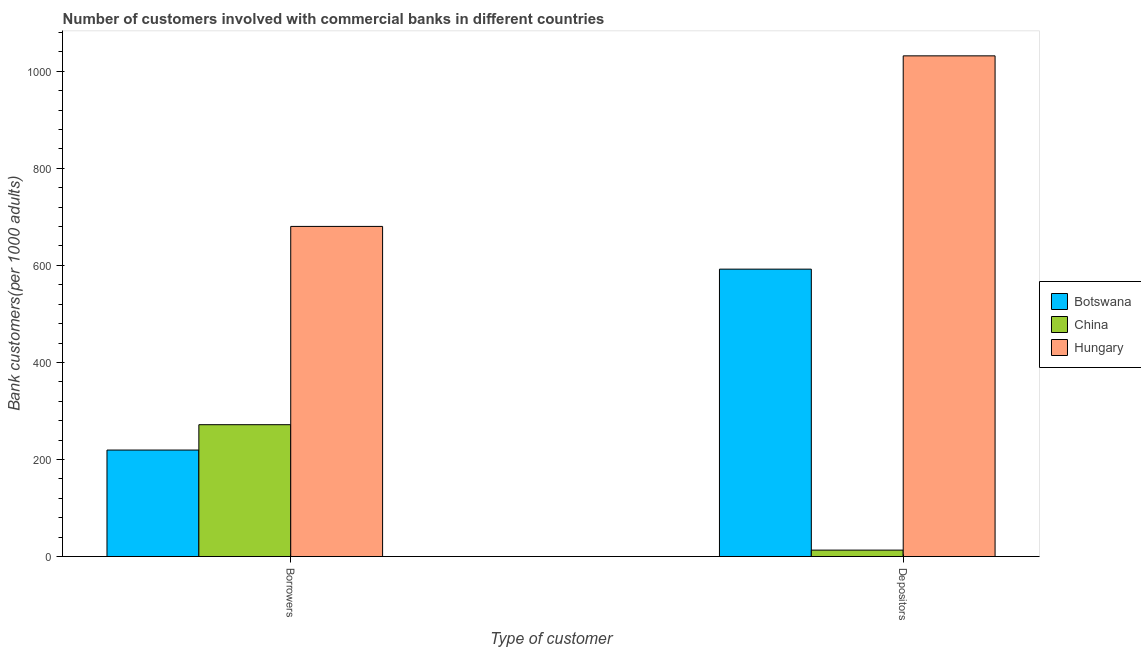How many different coloured bars are there?
Provide a succinct answer. 3. What is the label of the 1st group of bars from the left?
Offer a very short reply. Borrowers. What is the number of borrowers in Botswana?
Ensure brevity in your answer.  219.44. Across all countries, what is the maximum number of borrowers?
Give a very brief answer. 680.32. Across all countries, what is the minimum number of borrowers?
Your answer should be compact. 219.44. In which country was the number of depositors maximum?
Keep it short and to the point. Hungary. In which country was the number of borrowers minimum?
Provide a short and direct response. Botswana. What is the total number of borrowers in the graph?
Your answer should be very brief. 1171.47. What is the difference between the number of depositors in Botswana and that in Hungary?
Your answer should be compact. -439.55. What is the difference between the number of borrowers in Botswana and the number of depositors in Hungary?
Your response must be concise. -812.38. What is the average number of depositors per country?
Offer a terse response. 545.77. What is the difference between the number of borrowers and number of depositors in Botswana?
Your response must be concise. -372.82. In how many countries, is the number of depositors greater than 520 ?
Ensure brevity in your answer.  2. What is the ratio of the number of borrowers in China to that in Botswana?
Give a very brief answer. 1.24. What does the 2nd bar from the left in Borrowers represents?
Your response must be concise. China. What does the 3rd bar from the right in Depositors represents?
Give a very brief answer. Botswana. How many bars are there?
Your answer should be very brief. 6. Are all the bars in the graph horizontal?
Your response must be concise. No. What is the difference between two consecutive major ticks on the Y-axis?
Offer a very short reply. 200. Does the graph contain any zero values?
Ensure brevity in your answer.  No. Does the graph contain grids?
Provide a short and direct response. No. How many legend labels are there?
Provide a succinct answer. 3. What is the title of the graph?
Keep it short and to the point. Number of customers involved with commercial banks in different countries. Does "Liberia" appear as one of the legend labels in the graph?
Offer a terse response. No. What is the label or title of the X-axis?
Provide a succinct answer. Type of customer. What is the label or title of the Y-axis?
Give a very brief answer. Bank customers(per 1000 adults). What is the Bank customers(per 1000 adults) of Botswana in Borrowers?
Offer a terse response. 219.44. What is the Bank customers(per 1000 adults) in China in Borrowers?
Your answer should be compact. 271.71. What is the Bank customers(per 1000 adults) of Hungary in Borrowers?
Your answer should be very brief. 680.32. What is the Bank customers(per 1000 adults) in Botswana in Depositors?
Offer a very short reply. 592.26. What is the Bank customers(per 1000 adults) of China in Depositors?
Keep it short and to the point. 13.23. What is the Bank customers(per 1000 adults) in Hungary in Depositors?
Your answer should be very brief. 1031.82. Across all Type of customer, what is the maximum Bank customers(per 1000 adults) of Botswana?
Provide a short and direct response. 592.26. Across all Type of customer, what is the maximum Bank customers(per 1000 adults) of China?
Offer a very short reply. 271.71. Across all Type of customer, what is the maximum Bank customers(per 1000 adults) in Hungary?
Your answer should be very brief. 1031.82. Across all Type of customer, what is the minimum Bank customers(per 1000 adults) of Botswana?
Your answer should be compact. 219.44. Across all Type of customer, what is the minimum Bank customers(per 1000 adults) of China?
Offer a very short reply. 13.23. Across all Type of customer, what is the minimum Bank customers(per 1000 adults) in Hungary?
Ensure brevity in your answer.  680.32. What is the total Bank customers(per 1000 adults) in Botswana in the graph?
Offer a very short reply. 811.7. What is the total Bank customers(per 1000 adults) of China in the graph?
Offer a very short reply. 284.94. What is the total Bank customers(per 1000 adults) of Hungary in the graph?
Give a very brief answer. 1712.13. What is the difference between the Bank customers(per 1000 adults) of Botswana in Borrowers and that in Depositors?
Offer a terse response. -372.82. What is the difference between the Bank customers(per 1000 adults) of China in Borrowers and that in Depositors?
Your answer should be very brief. 258.48. What is the difference between the Bank customers(per 1000 adults) of Hungary in Borrowers and that in Depositors?
Keep it short and to the point. -351.5. What is the difference between the Bank customers(per 1000 adults) in Botswana in Borrowers and the Bank customers(per 1000 adults) in China in Depositors?
Ensure brevity in your answer.  206.2. What is the difference between the Bank customers(per 1000 adults) in Botswana in Borrowers and the Bank customers(per 1000 adults) in Hungary in Depositors?
Your answer should be very brief. -812.38. What is the difference between the Bank customers(per 1000 adults) in China in Borrowers and the Bank customers(per 1000 adults) in Hungary in Depositors?
Your answer should be very brief. -760.1. What is the average Bank customers(per 1000 adults) in Botswana per Type of customer?
Provide a short and direct response. 405.85. What is the average Bank customers(per 1000 adults) of China per Type of customer?
Offer a very short reply. 142.47. What is the average Bank customers(per 1000 adults) of Hungary per Type of customer?
Provide a succinct answer. 856.07. What is the difference between the Bank customers(per 1000 adults) in Botswana and Bank customers(per 1000 adults) in China in Borrowers?
Keep it short and to the point. -52.27. What is the difference between the Bank customers(per 1000 adults) in Botswana and Bank customers(per 1000 adults) in Hungary in Borrowers?
Your answer should be very brief. -460.88. What is the difference between the Bank customers(per 1000 adults) of China and Bank customers(per 1000 adults) of Hungary in Borrowers?
Provide a succinct answer. -408.61. What is the difference between the Bank customers(per 1000 adults) in Botswana and Bank customers(per 1000 adults) in China in Depositors?
Your answer should be very brief. 579.03. What is the difference between the Bank customers(per 1000 adults) of Botswana and Bank customers(per 1000 adults) of Hungary in Depositors?
Give a very brief answer. -439.55. What is the difference between the Bank customers(per 1000 adults) in China and Bank customers(per 1000 adults) in Hungary in Depositors?
Offer a very short reply. -1018.58. What is the ratio of the Bank customers(per 1000 adults) of Botswana in Borrowers to that in Depositors?
Your answer should be very brief. 0.37. What is the ratio of the Bank customers(per 1000 adults) in China in Borrowers to that in Depositors?
Your response must be concise. 20.53. What is the ratio of the Bank customers(per 1000 adults) of Hungary in Borrowers to that in Depositors?
Your response must be concise. 0.66. What is the difference between the highest and the second highest Bank customers(per 1000 adults) in Botswana?
Give a very brief answer. 372.82. What is the difference between the highest and the second highest Bank customers(per 1000 adults) in China?
Offer a very short reply. 258.48. What is the difference between the highest and the second highest Bank customers(per 1000 adults) of Hungary?
Your answer should be very brief. 351.5. What is the difference between the highest and the lowest Bank customers(per 1000 adults) in Botswana?
Offer a very short reply. 372.82. What is the difference between the highest and the lowest Bank customers(per 1000 adults) of China?
Make the answer very short. 258.48. What is the difference between the highest and the lowest Bank customers(per 1000 adults) in Hungary?
Your answer should be compact. 351.5. 